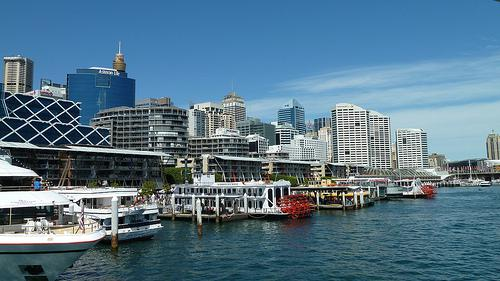Question: what is this picture of?
Choices:
A. A garage.
B. A marina.
C. A car.
D. A telephone.
Answer with the letter. Answer: B Question: who is in the picture?
Choices:
A. People.
B. No one.
C. Dogs.
D. Kittens.
Answer with the letter. Answer: B Question: what color is the wheel on the boats?
Choices:
A. Black.
B. Red.
C. Gray.
D. Green.
Answer with the letter. Answer: B 